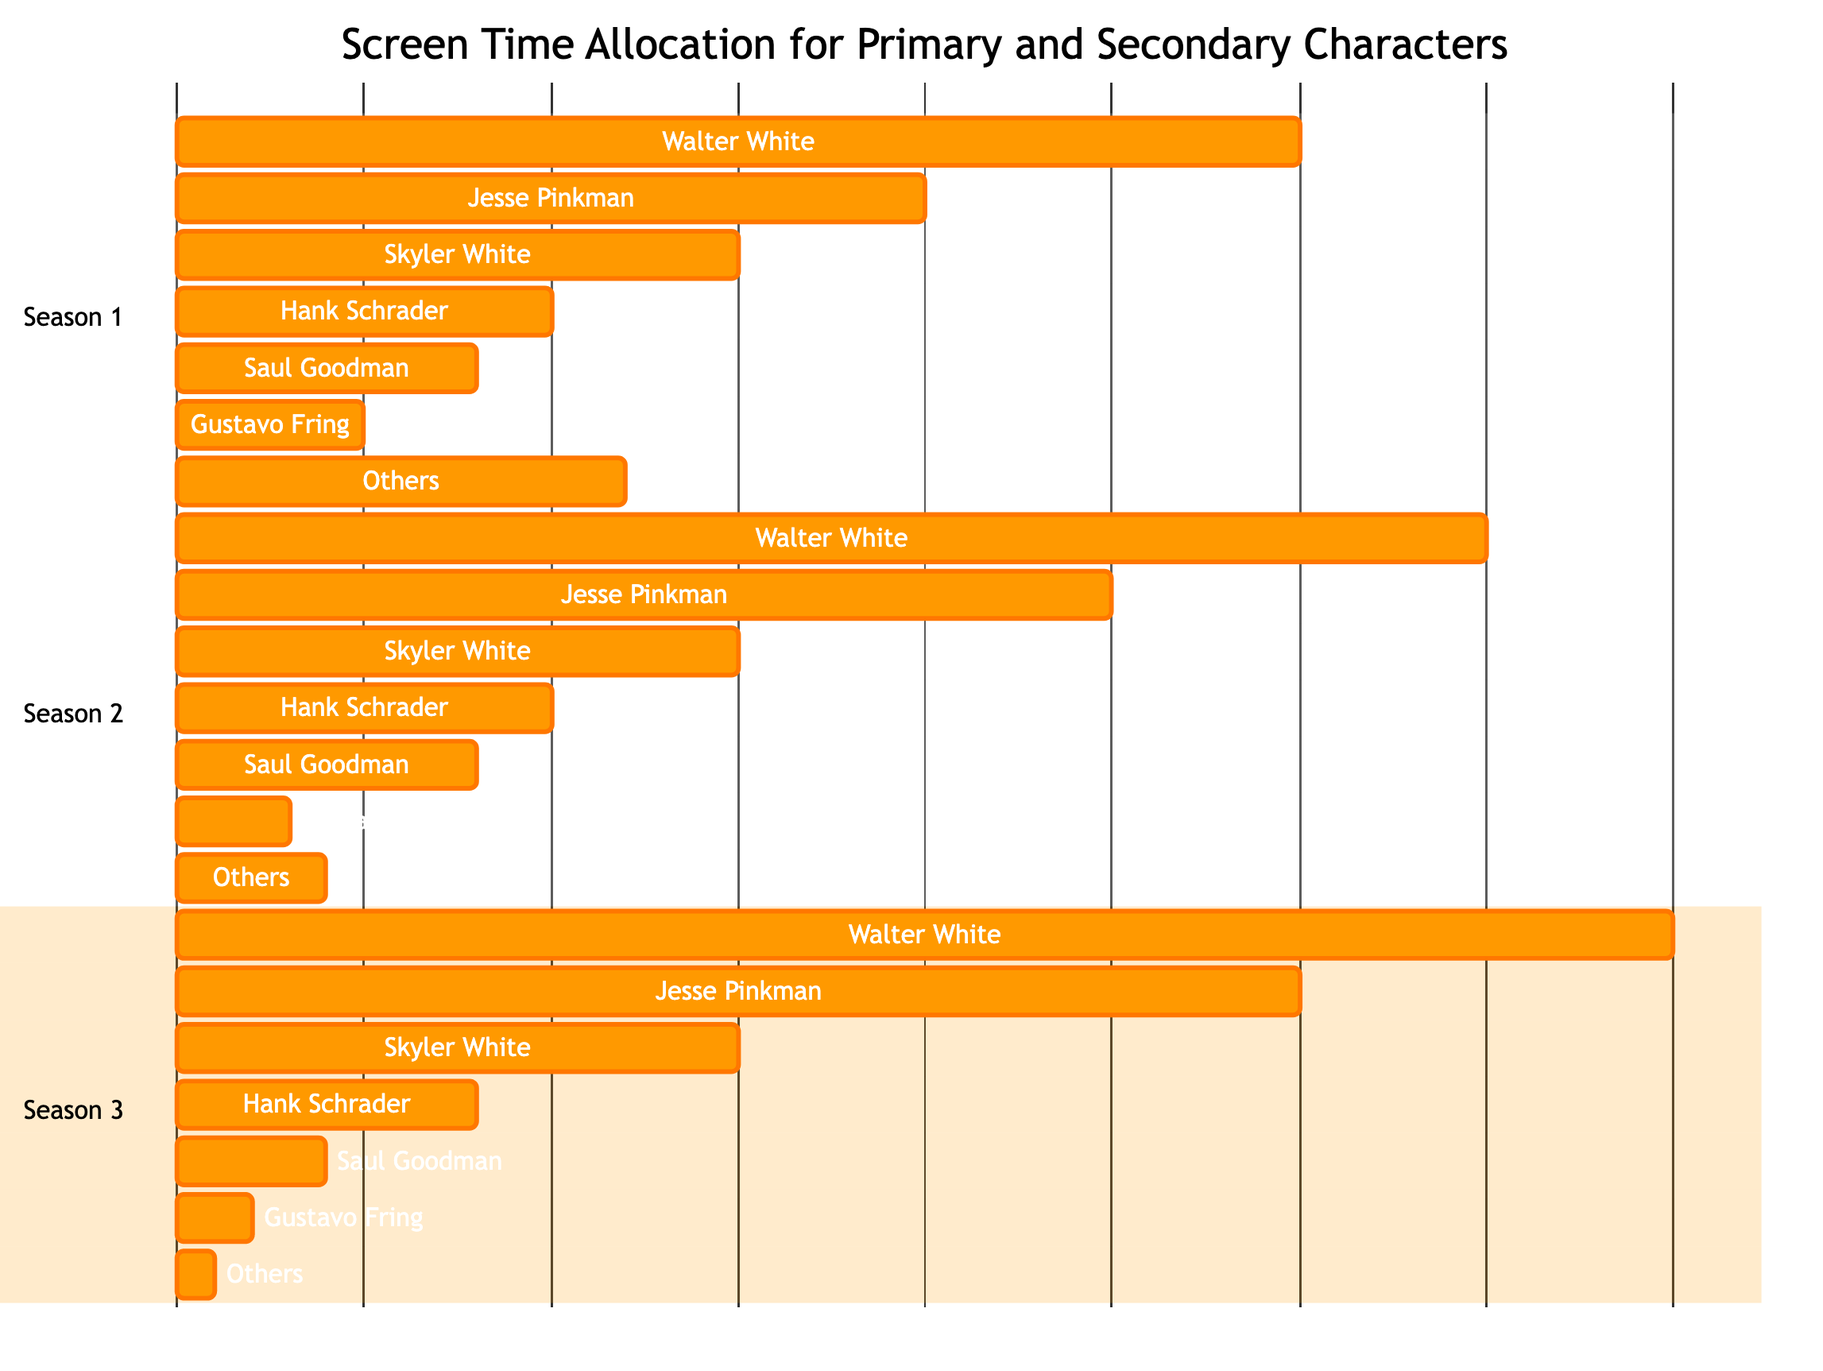What is the total screen time for Walter White in Season 1? In Season 1, Walter White has a screen time allocation of 30. This is found in the section for Season 1 where Walter White's time is explicitly listed.
Answer: 30 Which character had the least screen time in Season 2? In Season 2, the characters are listed with their respective screen time. Gustavo Fring has a screen time allocation of 3, which is the lowest compared to other characters in that season.
Answer: Gustavo Fring What is the total screen time for Jesse Pinkman over all three seasons? By adding his screen time from each season: Season 1 (20) + Season 2 (25) + Season 3 (30) = 75. Thus, Jesse Pinkman's total screen time is the sum of these values across all provided seasons.
Answer: 75 How much more screen time did Walter White have than Skyler White in Season 3? In Season 3, Walter White has 40 and Skyler White has 15. The difference is calculated as 40 - 15 = 25, indicating Walter White had 25 more minutes of screen time than Skyler in that season.
Answer: 25 What is the combined screen time for 'Others' across all seasons? The screen time for 'Others' is as follows: Season 1 (12) + Season 2 (4) + Season 3 (1) = 17, thus the total combined screen time for 'Others' across all seasons is the sum of these values.
Answer: 17 Which season had the highest total screen time allocated to primary characters? By calculating the total screen time for primary characters in each season: Season 1 (30 + 20 = 50) + Season 2 (35 + 25 = 60) + Season 3 (40 + 30 = 70), we find Season 3 has the highest total screen time for primary characters.
Answer: Season 3 What percentage of total screen time did Saul Goodman receive in Season 1? In Season 1, Saul Goodman had 8 minutes of screen time. The total time for all characters in that season is 30 + 20 + 15 + 10 + 8 + 5 + 12 = 100 minutes. The percentage is calculated as (8/100) * 100 = 8%.
Answer: 8% How did the screen time for Gustavo Fring change from Season 1 to Season 3? In Season 1, Gustavo Fring had 5 minutes, and in Season 3, he had 2 minutes. Therefore, his screen time decreased by 3 minutes from Season 1 to Season 3 (5 - 2 = 3).
Answer: Decreased by 3 Which character consistently had the highest screen time across all three seasons? By reviewing the screen time data for each character in every season, it is clear that Walter White always had the highest screen time for each season: 30 in Season 1, 35 in Season 2, and 40 in Season 3.
Answer: Walter White 